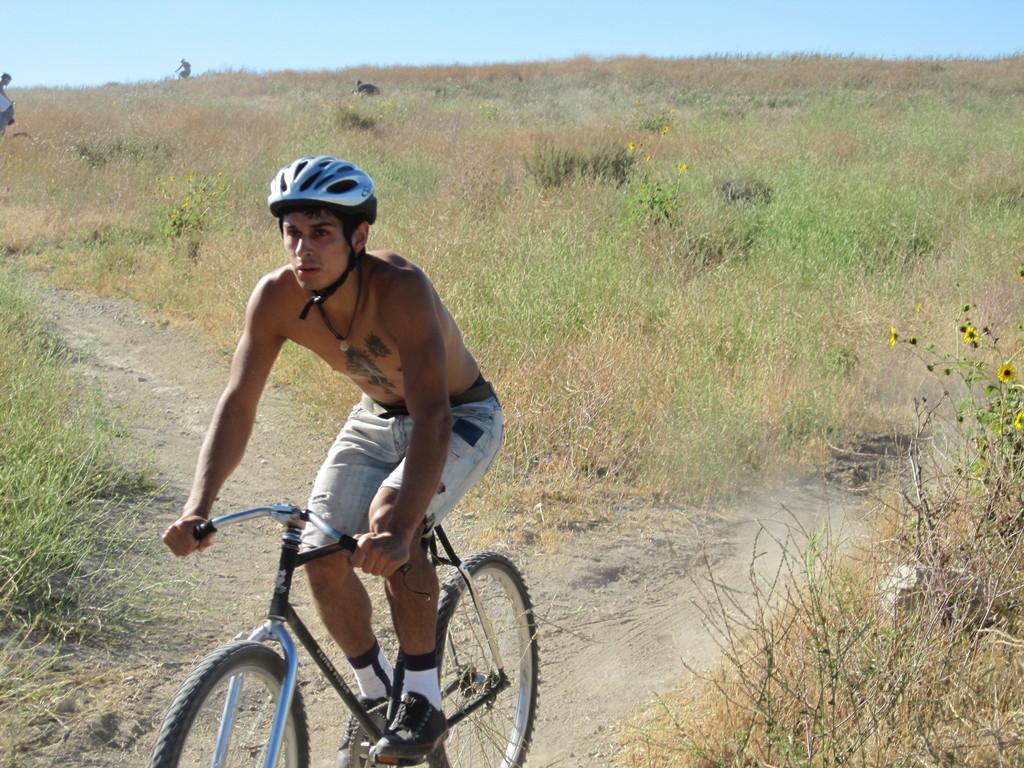Could you give a brief overview of what you see in this image? in this picture we can see a person riding a cycle by wearing a helmet,we can also see a grass,we can also see the clear sky. 